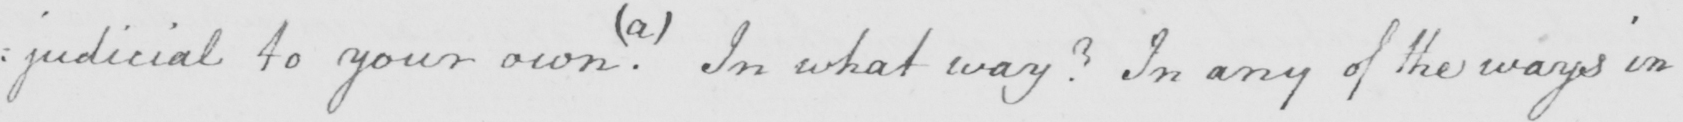Please provide the text content of this handwritten line. : judicial to your own  . In what way ?  In any of the ways in 